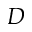Convert formula to latex. <formula><loc_0><loc_0><loc_500><loc_500>D</formula> 